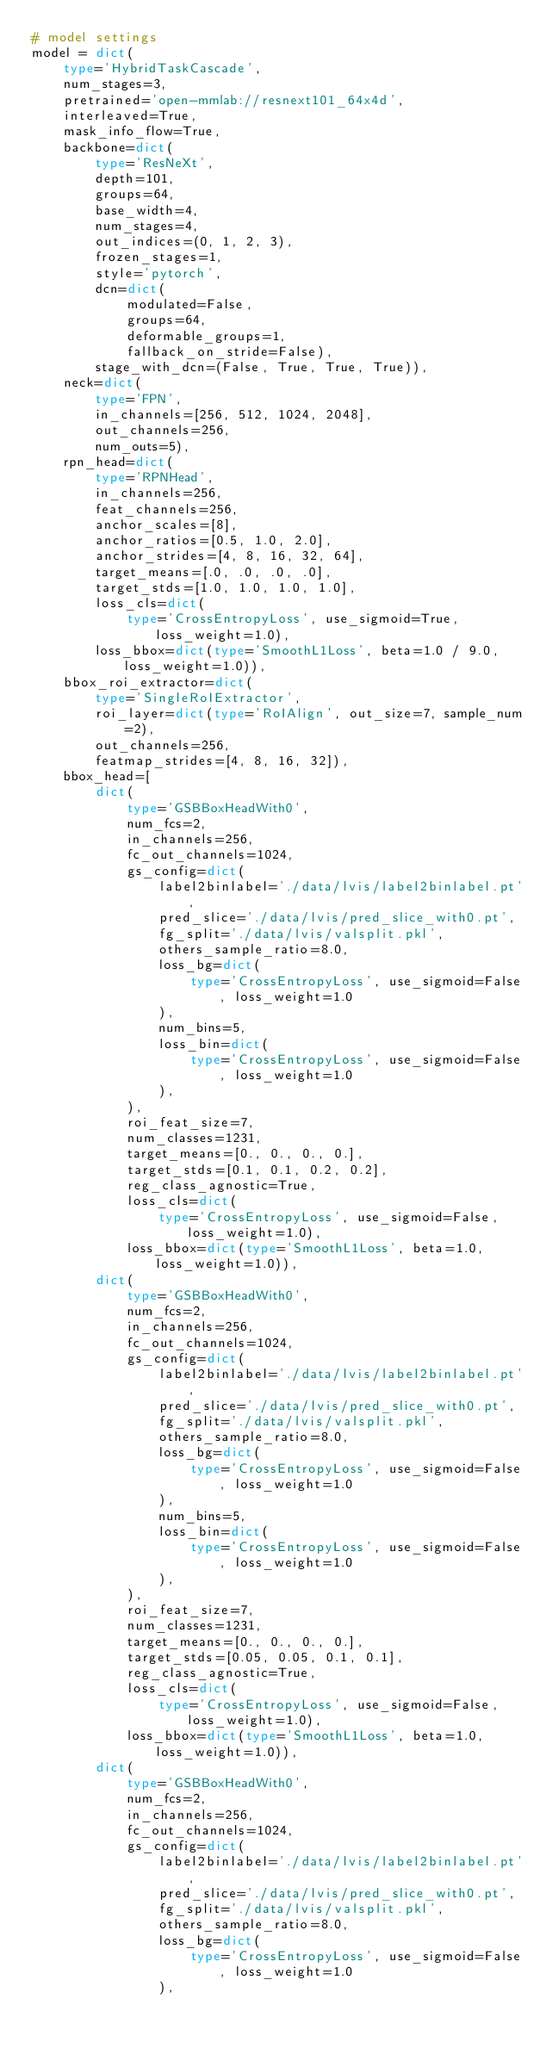<code> <loc_0><loc_0><loc_500><loc_500><_Python_># model settings
model = dict(
    type='HybridTaskCascade',
    num_stages=3,
    pretrained='open-mmlab://resnext101_64x4d',
    interleaved=True,
    mask_info_flow=True,
    backbone=dict(
        type='ResNeXt',
        depth=101,
        groups=64,
        base_width=4,
        num_stages=4,
        out_indices=(0, 1, 2, 3),
        frozen_stages=1,
        style='pytorch',
        dcn=dict(
            modulated=False,
            groups=64,
            deformable_groups=1,
            fallback_on_stride=False),
        stage_with_dcn=(False, True, True, True)),
    neck=dict(
        type='FPN',
        in_channels=[256, 512, 1024, 2048],
        out_channels=256,
        num_outs=5),
    rpn_head=dict(
        type='RPNHead',
        in_channels=256,
        feat_channels=256,
        anchor_scales=[8],
        anchor_ratios=[0.5, 1.0, 2.0],
        anchor_strides=[4, 8, 16, 32, 64],
        target_means=[.0, .0, .0, .0],
        target_stds=[1.0, 1.0, 1.0, 1.0],
        loss_cls=dict(
            type='CrossEntropyLoss', use_sigmoid=True, loss_weight=1.0),
        loss_bbox=dict(type='SmoothL1Loss', beta=1.0 / 9.0, loss_weight=1.0)),
    bbox_roi_extractor=dict(
        type='SingleRoIExtractor',
        roi_layer=dict(type='RoIAlign', out_size=7, sample_num=2),
        out_channels=256,
        featmap_strides=[4, 8, 16, 32]),
    bbox_head=[
        dict(
            type='GSBBoxHeadWith0',
            num_fcs=2,
            in_channels=256,
            fc_out_channels=1024,
            gs_config=dict(
                label2binlabel='./data/lvis/label2binlabel.pt',
                pred_slice='./data/lvis/pred_slice_with0.pt',
                fg_split='./data/lvis/valsplit.pkl',
                others_sample_ratio=8.0,
                loss_bg=dict(
                    type='CrossEntropyLoss', use_sigmoid=False, loss_weight=1.0
                ),
                num_bins=5,
                loss_bin=dict(
                    type='CrossEntropyLoss', use_sigmoid=False, loss_weight=1.0
                ),
            ),
            roi_feat_size=7,
            num_classes=1231,
            target_means=[0., 0., 0., 0.],
            target_stds=[0.1, 0.1, 0.2, 0.2],
            reg_class_agnostic=True,
            loss_cls=dict(
                type='CrossEntropyLoss', use_sigmoid=False, loss_weight=1.0),
            loss_bbox=dict(type='SmoothL1Loss', beta=1.0, loss_weight=1.0)),
        dict(
            type='GSBBoxHeadWith0',
            num_fcs=2,
            in_channels=256,
            fc_out_channels=1024,
            gs_config=dict(
                label2binlabel='./data/lvis/label2binlabel.pt',
                pred_slice='./data/lvis/pred_slice_with0.pt',
                fg_split='./data/lvis/valsplit.pkl',
                others_sample_ratio=8.0,
                loss_bg=dict(
                    type='CrossEntropyLoss', use_sigmoid=False, loss_weight=1.0
                ),
                num_bins=5,
                loss_bin=dict(
                    type='CrossEntropyLoss', use_sigmoid=False, loss_weight=1.0
                ),
            ),
            roi_feat_size=7,
            num_classes=1231,
            target_means=[0., 0., 0., 0.],
            target_stds=[0.05, 0.05, 0.1, 0.1],
            reg_class_agnostic=True,
            loss_cls=dict(
                type='CrossEntropyLoss', use_sigmoid=False, loss_weight=1.0),
            loss_bbox=dict(type='SmoothL1Loss', beta=1.0, loss_weight=1.0)),
        dict(
            type='GSBBoxHeadWith0',
            num_fcs=2,
            in_channels=256,
            fc_out_channels=1024,
            gs_config=dict(
                label2binlabel='./data/lvis/label2binlabel.pt',
                pred_slice='./data/lvis/pred_slice_with0.pt',
                fg_split='./data/lvis/valsplit.pkl',
                others_sample_ratio=8.0,
                loss_bg=dict(
                    type='CrossEntropyLoss', use_sigmoid=False, loss_weight=1.0
                ),</code> 